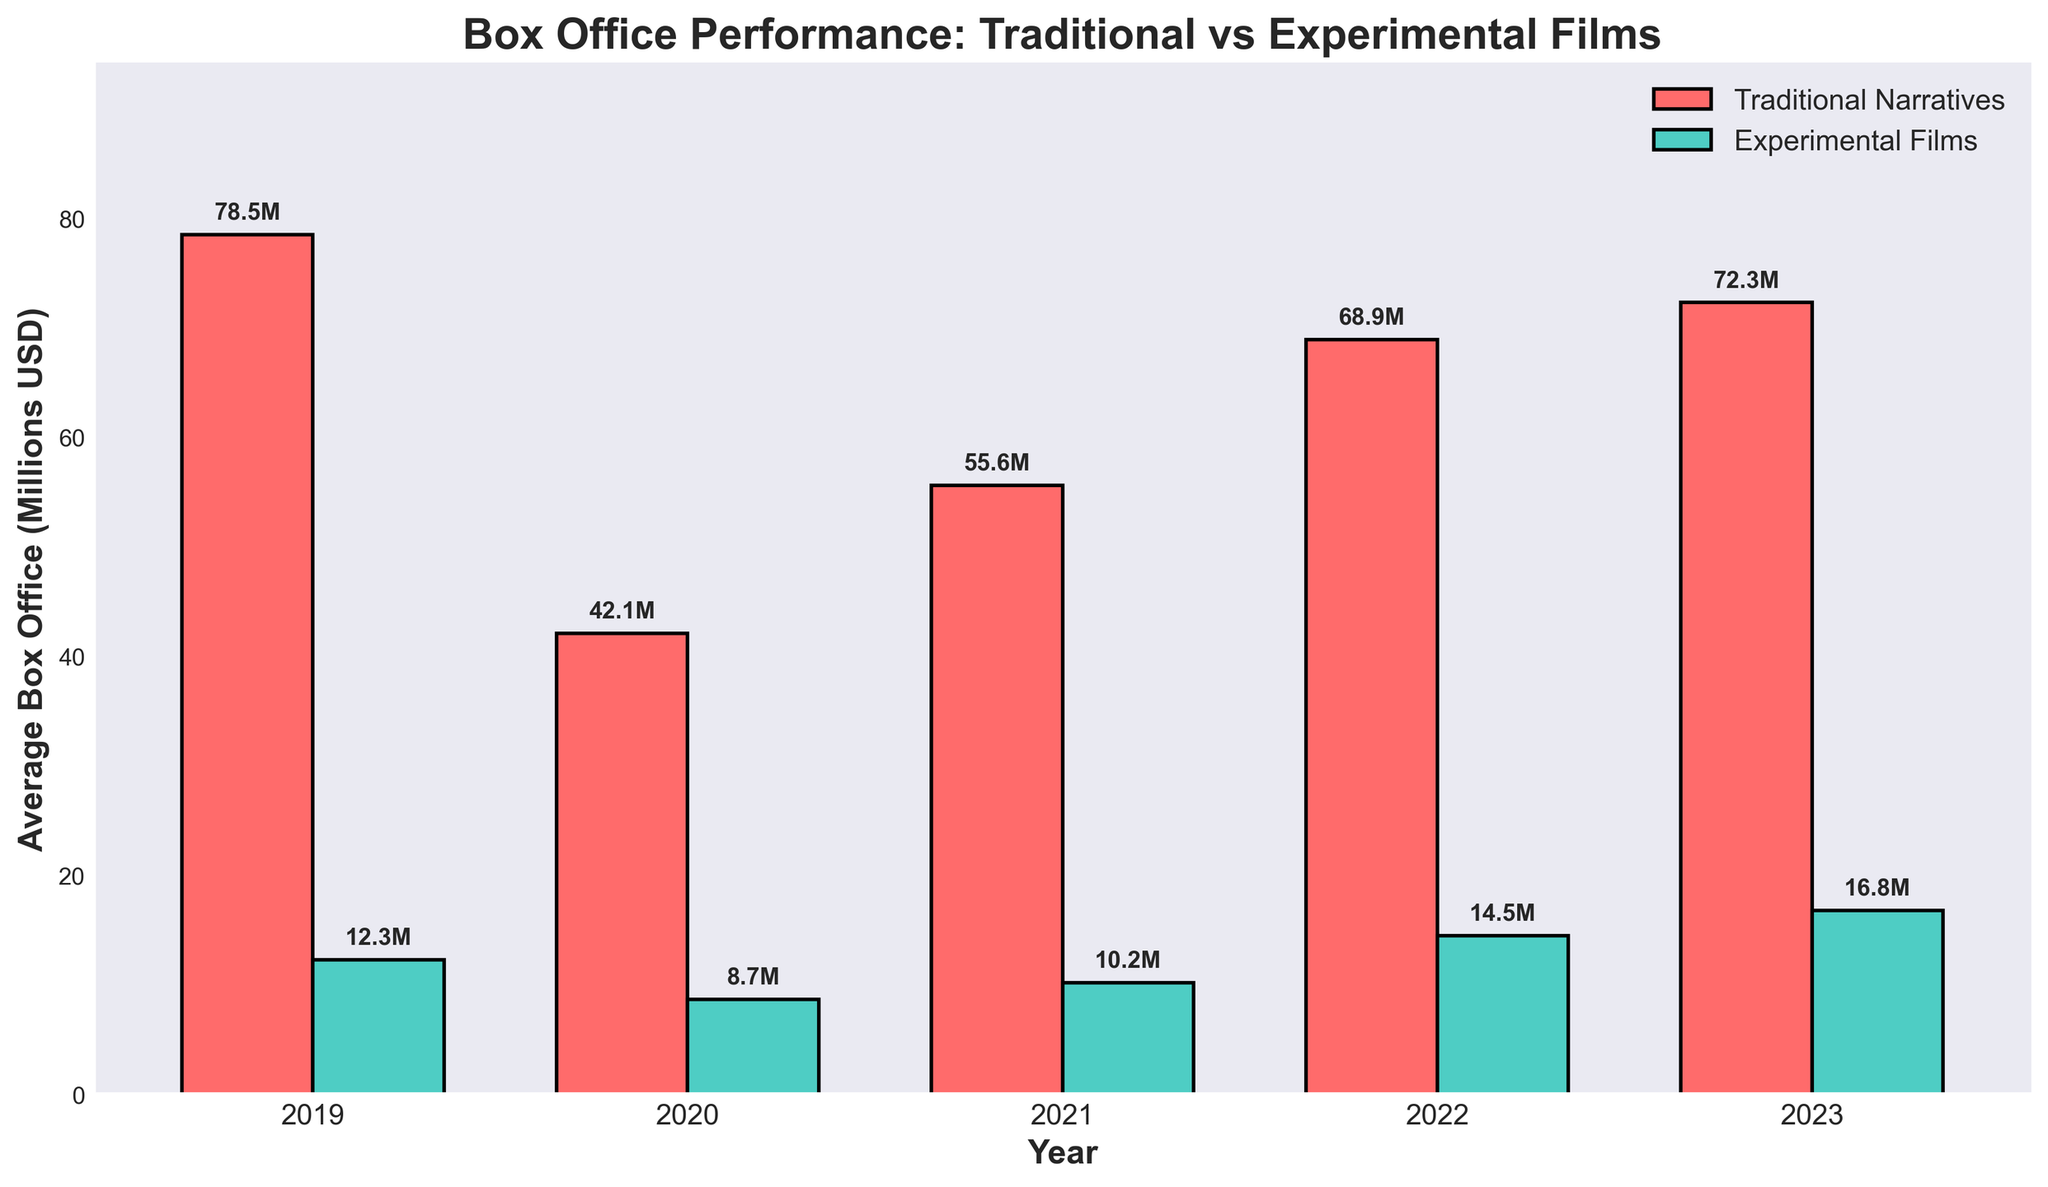How does the box office performance of experimental films in 2023 compare to 2019? The box office performance of experimental films in 2023 is represented by a green bar labeled 16.8 million USD, whereas in 2019 it is represented by a green bar labeled 12.3 million USD. To compare, subtract 12.3 from 16.8.
Answer: 4.5 million USD higher Which year had the highest average box office performance for traditional narratives? Identify the tallest red bar among the years for traditional narratives. The red bar labeled 78.5 million USD in 2019 is the highest.
Answer: 2019 What is the total average box office performance for experimental films over the five years? Sum the values for experimental films: 12.3 (2019) + 8.7 (2020) + 10.2 (2021) + 14.5 (2022) + 16.8 (2023).
Answer: 62.5 million USD Did traditional narratives outperform experimental films every year? Compare red bars (traditional narratives) to green bars (experimental films) year by year. In each case, the red bar is taller.
Answer: Yes What's the difference between the highest and lowest average box office performances of experimental films? Identify the highest value (16.8 million USD in 2023) and the lowest (8.7 million USD in 2020), then subtract the lowest from the highest.
Answer: 8.1 million USD What trend do we observe in the average box office of experimental films from 2019 to 2023? Track the heights of the green bars from 2019 (12.3) through 2020 (8.7), 2021 (10.2), 2022 (14.5), to 2023 (16.8). The trend shows fluctuations but an overall increase.
Answer: Increasing In 2021, how much more did traditional narratives earn than experimental films on average? The red bar (traditional narratives) is 55.6 million USD, and the green bar (experimental films) is 10.2 million USD in 2021. Subtract 10.2 from 55.6.
Answer: 45.4 million USD What is the average box office performance of traditional narratives across all five years? Sum the values of traditional narratives, then divide by five: (78.5 + 42.1 + 55.6 + 68.9 + 72.3) / 5.
Answer: 63.48 million USD 